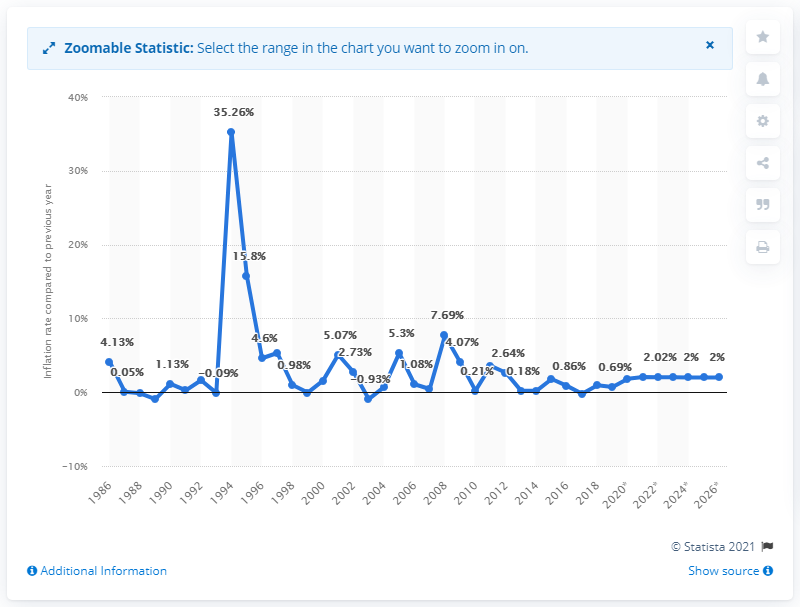Identify some key points in this picture. The average inflation rate in Togo was in 1986. 